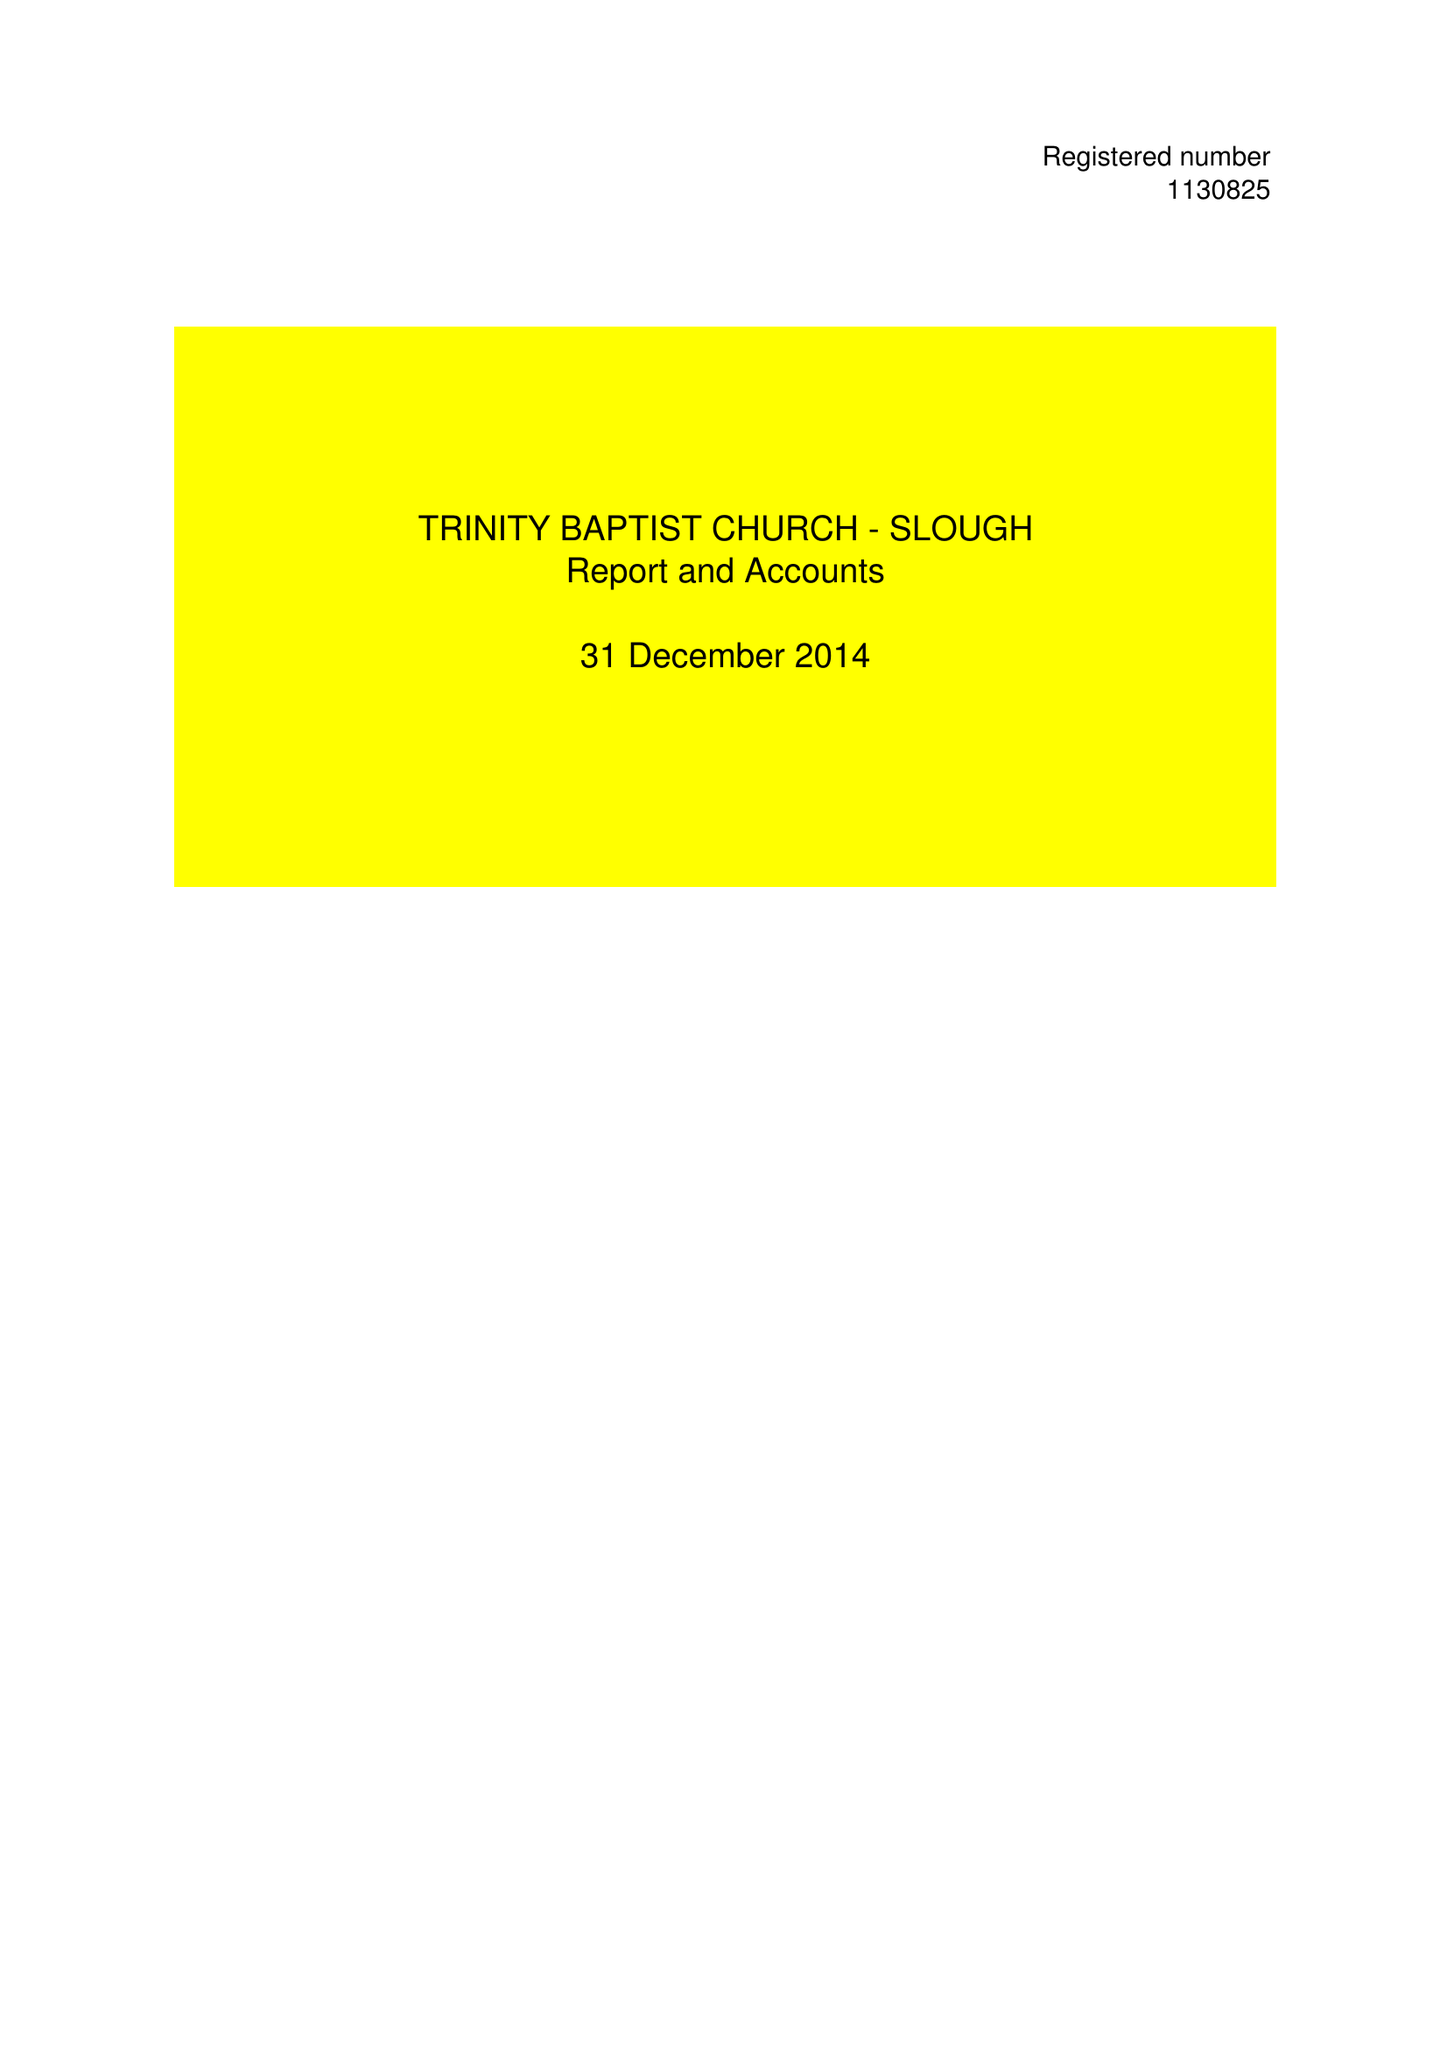What is the value for the report_date?
Answer the question using a single word or phrase. 2014-12-31 